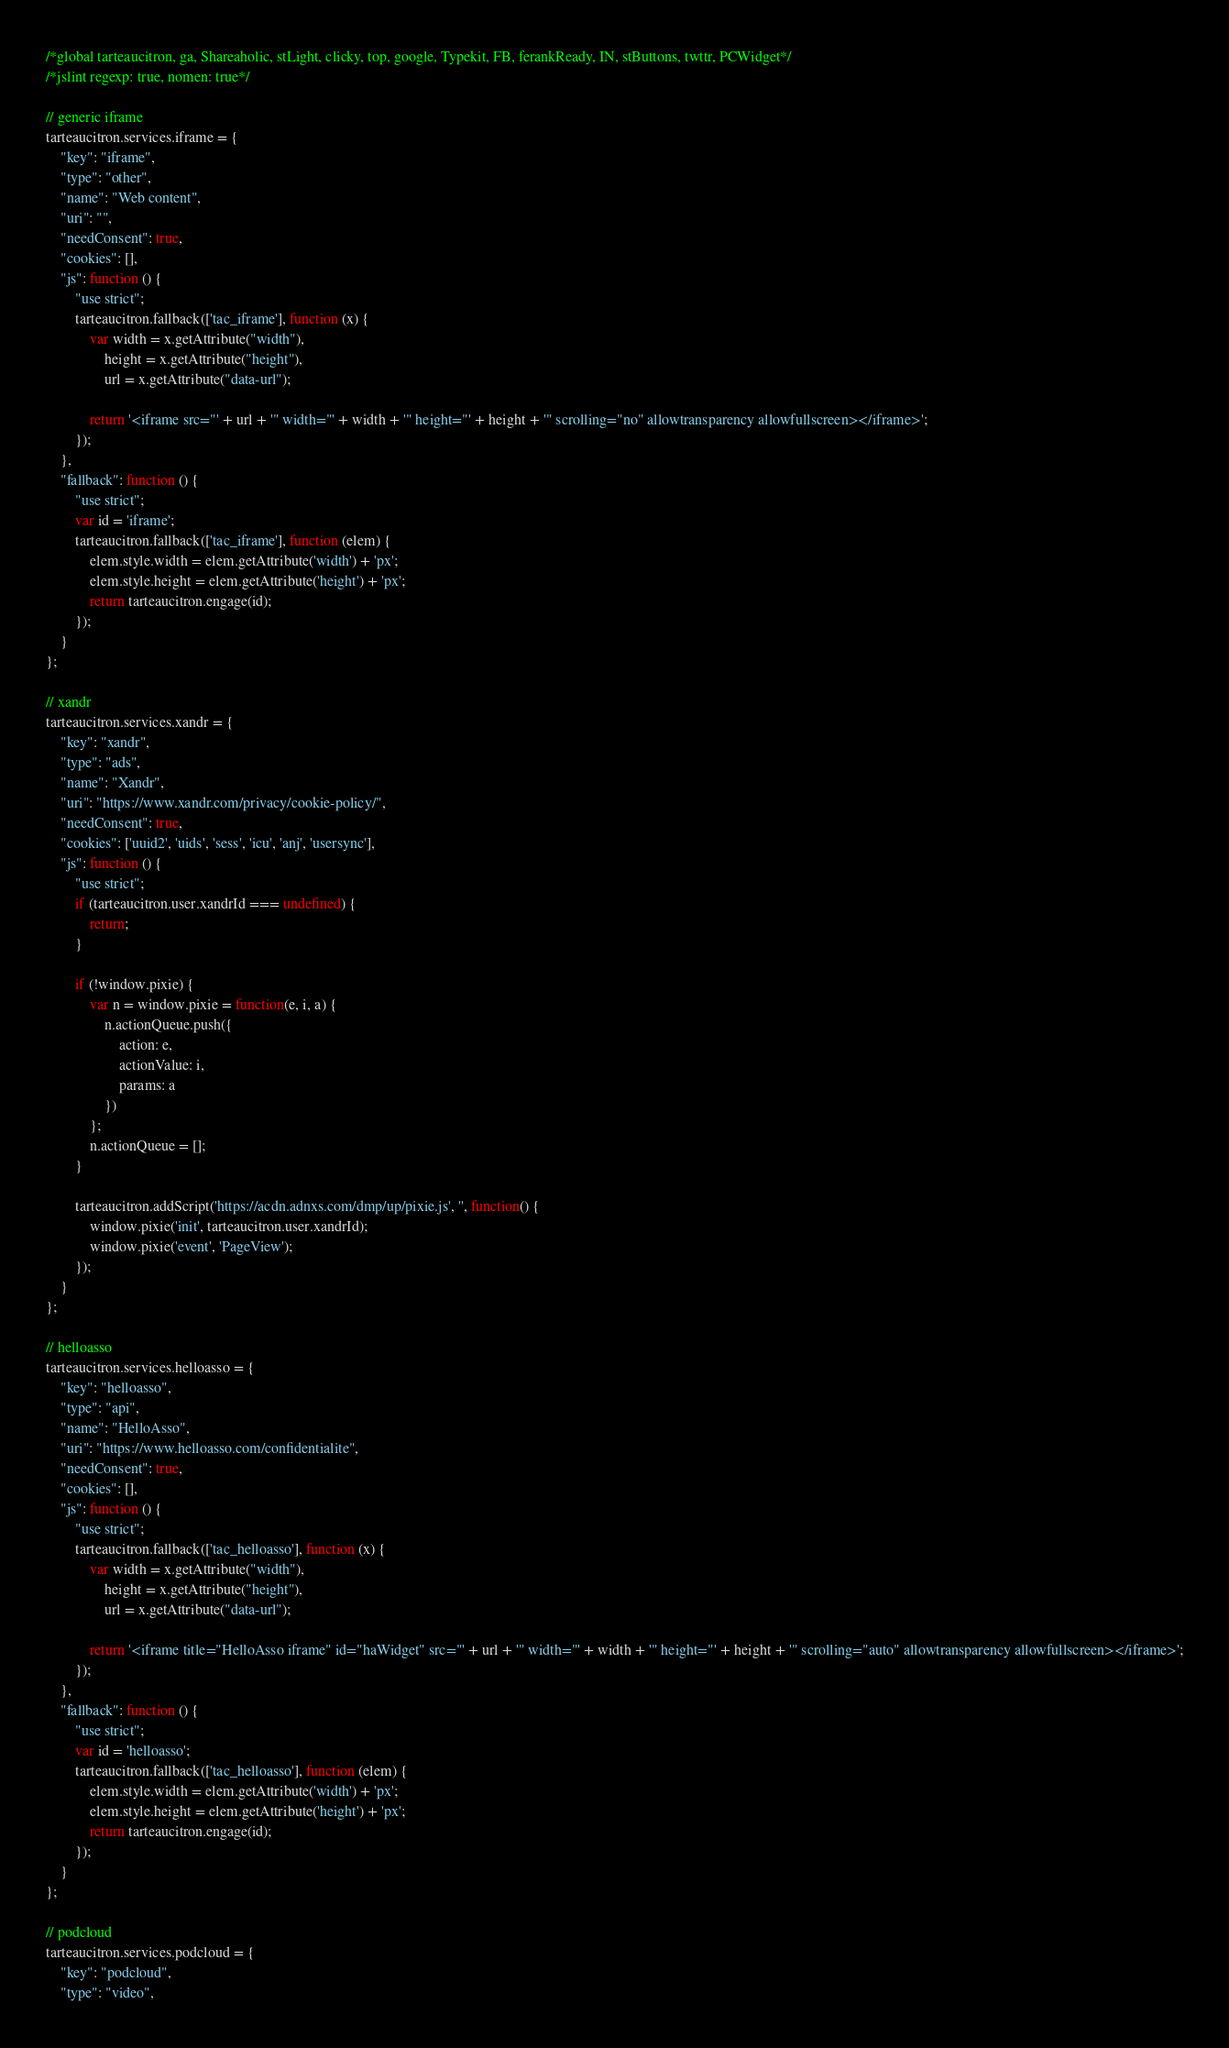<code> <loc_0><loc_0><loc_500><loc_500><_JavaScript_>/*global tarteaucitron, ga, Shareaholic, stLight, clicky, top, google, Typekit, FB, ferankReady, IN, stButtons, twttr, PCWidget*/
/*jslint regexp: true, nomen: true*/

// generic iframe
tarteaucitron.services.iframe = {
    "key": "iframe",
    "type": "other",
    "name": "Web content",
    "uri": "",
    "needConsent": true,
    "cookies": [],
    "js": function () {
        "use strict";
        tarteaucitron.fallback(['tac_iframe'], function (x) {
            var width = x.getAttribute("width"),
                height = x.getAttribute("height"),
                url = x.getAttribute("data-url");

            return '<iframe src="' + url + '" width="' + width + '" height="' + height + '" scrolling="no" allowtransparency allowfullscreen></iframe>';
        });
    },
    "fallback": function () {
        "use strict";
        var id = 'iframe';
        tarteaucitron.fallback(['tac_iframe'], function (elem) {
            elem.style.width = elem.getAttribute('width') + 'px';
            elem.style.height = elem.getAttribute('height') + 'px';
            return tarteaucitron.engage(id);
        });
    }
};

// xandr
tarteaucitron.services.xandr = {
    "key": "xandr",
    "type": "ads",
    "name": "Xandr",
    "uri": "https://www.xandr.com/privacy/cookie-policy/",
    "needConsent": true,
    "cookies": ['uuid2', 'uids', 'sess', 'icu', 'anj', 'usersync'],
    "js": function () {
        "use strict";
        if (tarteaucitron.user.xandrId === undefined) {
            return;
        }

        if (!window.pixie) {
            var n = window.pixie = function(e, i, a) {
                n.actionQueue.push({
                    action: e,
                    actionValue: i,
                    params: a
                })
            };
            n.actionQueue = [];
        }

        tarteaucitron.addScript('https://acdn.adnxs.com/dmp/up/pixie.js', '', function() {
            window.pixie('init', tarteaucitron.user.xandrId);
            window.pixie('event', 'PageView');
        });
    }
};

// helloasso
tarteaucitron.services.helloasso = {
    "key": "helloasso",
    "type": "api",
    "name": "HelloAsso",
    "uri": "https://www.helloasso.com/confidentialite",
    "needConsent": true,
    "cookies": [],
    "js": function () {
        "use strict";
        tarteaucitron.fallback(['tac_helloasso'], function (x) {
            var width = x.getAttribute("width"),
                height = x.getAttribute("height"),
                url = x.getAttribute("data-url");

            return '<iframe title="HelloAsso iframe" id="haWidget" src="' + url + '" width="' + width + '" height="' + height + '" scrolling="auto" allowtransparency allowfullscreen></iframe>';
        });
    },
    "fallback": function () {
        "use strict";
        var id = 'helloasso';
        tarteaucitron.fallback(['tac_helloasso'], function (elem) {
            elem.style.width = elem.getAttribute('width') + 'px';
            elem.style.height = elem.getAttribute('height') + 'px';
            return tarteaucitron.engage(id);
        });
    }
};

// podcloud
tarteaucitron.services.podcloud = {
    "key": "podcloud",
    "type": "video",</code> 